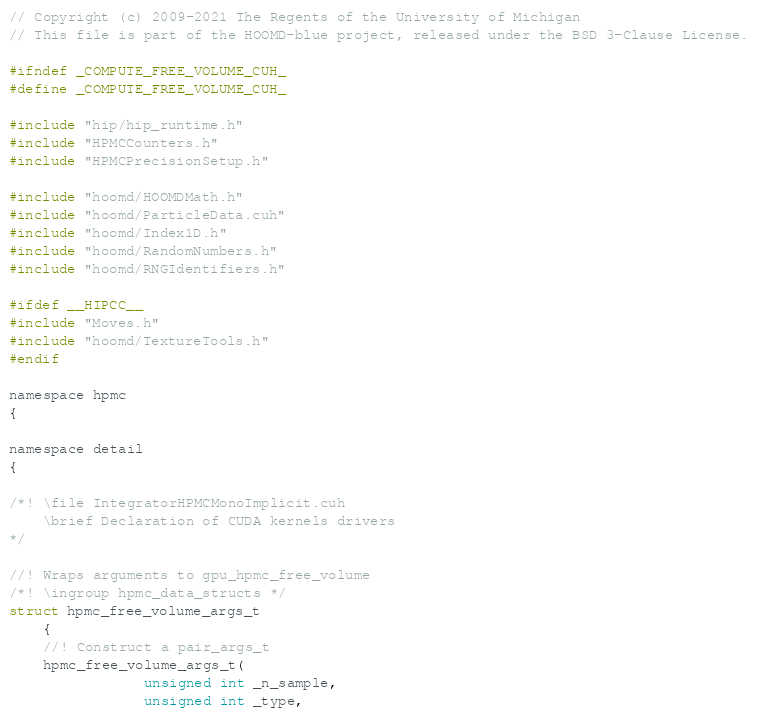<code> <loc_0><loc_0><loc_500><loc_500><_Cuda_>// Copyright (c) 2009-2021 The Regents of the University of Michigan
// This file is part of the HOOMD-blue project, released under the BSD 3-Clause License.

#ifndef _COMPUTE_FREE_VOLUME_CUH_
#define _COMPUTE_FREE_VOLUME_CUH_

#include "hip/hip_runtime.h"
#include "HPMCCounters.h"
#include "HPMCPrecisionSetup.h"

#include "hoomd/HOOMDMath.h"
#include "hoomd/ParticleData.cuh"
#include "hoomd/Index1D.h"
#include "hoomd/RandomNumbers.h"
#include "hoomd/RNGIdentifiers.h"

#ifdef __HIPCC__
#include "Moves.h"
#include "hoomd/TextureTools.h"
#endif

namespace hpmc
{

namespace detail
{

/*! \file IntegratorHPMCMonoImplicit.cuh
    \brief Declaration of CUDA kernels drivers
*/

//! Wraps arguments to gpu_hpmc_free_volume
/*! \ingroup hpmc_data_structs */
struct hpmc_free_volume_args_t
    {
    //! Construct a pair_args_t
    hpmc_free_volume_args_t(
                unsigned int _n_sample,
                unsigned int _type,</code> 